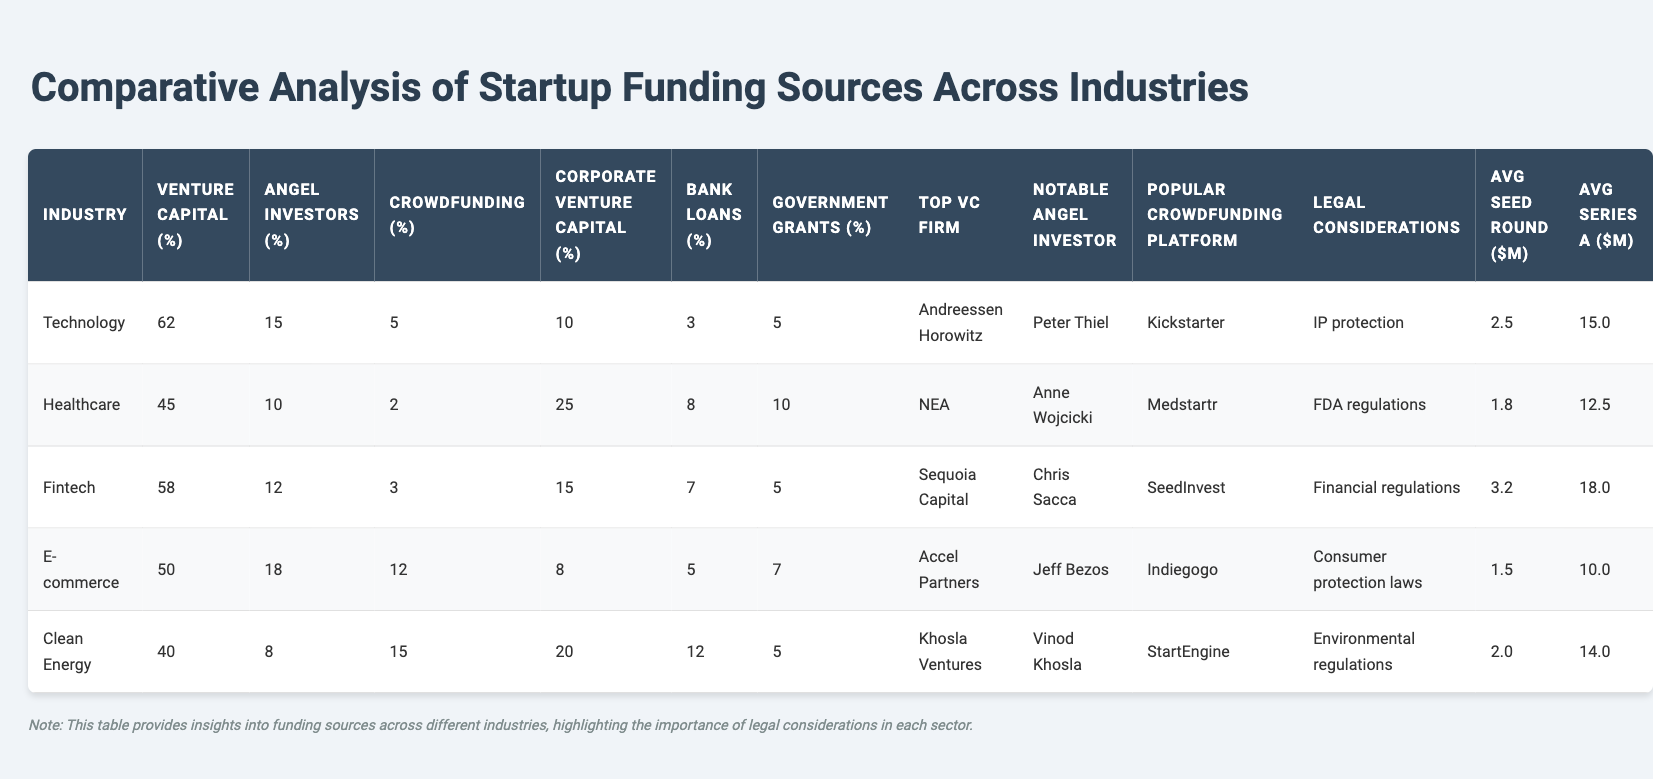What is the percentage of venture capital funding in the Technology industry? The table indicates that the percentage of venture capital funding in the Technology industry is 62%.
Answer: 62% Which industry has the highest percentage of crowdfunding? Based on the table, E-commerce has the highest percentage of crowdfunding at 12%.
Answer: E-commerce What is the average percentage of bank loans across all industries? To find the average percentage, we sum the bank loan percentages (3 + 8 + 7 + 5 + 12 = 35) and divide by the number of industries (5). So, the average is 35 / 5 = 7%.
Answer: 7% Is the notable angel investor for Healthcare the same as that for E-commerce? The notable angel investor for Healthcare is Anne Wojcicki, while for E-commerce, it is Jeff Bezos. Thus, they are not the same.
Answer: No Which industry has the lowest venture capital percentage, and what is that percentage? The Clean Energy industry has the lowest venture capital percentage, which is 40%.
Answer: Clean Energy, 40% If we compare the average seed round amounts of Technology and Healthcare, which is higher and by how much? The average seed round for Technology is $2.5M, and for Healthcare, it is $1.8M. The difference is $2.5M - $1.8M = $0.7M, indicating Technology has a higher amount by $0.7M.
Answer: Technology, $0.7M What percentage of funding does Corporate Venture Capital represent in the Clean Energy industry? The table shows that Corporate Venture Capital accounts for 20% in the Clean Energy industry.
Answer: 20% Which industry has the most notable angel investors with a higher average of funding amounts for both seed and Series A rounds? By comparing the average seed and Series A round amounts, Fintech with $3.2M for seed and $18.0M for Series A has the highest averages among the notable angel investors.
Answer: Fintech What is the percentage of angel investors in the Healthcare industry compared to the average across all industries? The percentage of angel investors in Healthcare is 10%. The average percentage across all industries is calculated as (15 + 10 + 12 + 18 + 8) / 5 = 12.6%. Since 10% is lower than 12.6%, Healthcare's percentage is below average.
Answer: Below average From the given data, does Clean Energy have a notable angel investor listed, and who is it? The table indicates that Vinod Khosla is the notable angel investor for Clean Energy.
Answer: Yes, Vinod Khosla 